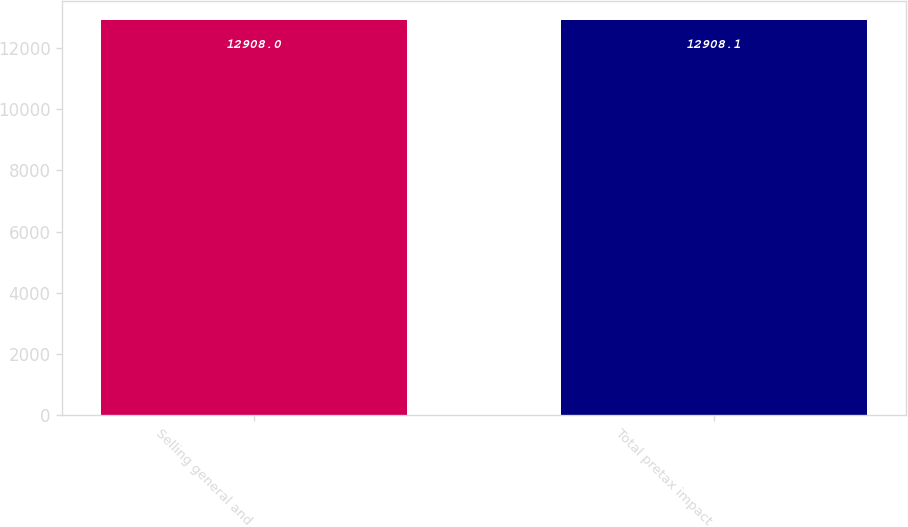Convert chart to OTSL. <chart><loc_0><loc_0><loc_500><loc_500><bar_chart><fcel>Selling general and<fcel>Total pretax impact<nl><fcel>12908<fcel>12908.1<nl></chart> 